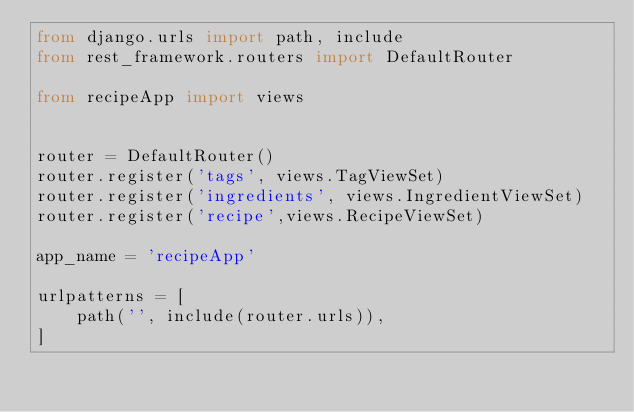Convert code to text. <code><loc_0><loc_0><loc_500><loc_500><_Python_>from django.urls import path, include
from rest_framework.routers import DefaultRouter

from recipeApp import views


router = DefaultRouter()
router.register('tags', views.TagViewSet)
router.register('ingredients', views.IngredientViewSet)
router.register('recipe',views.RecipeViewSet)

app_name = 'recipeApp'

urlpatterns = [
    path('', include(router.urls)),
]</code> 